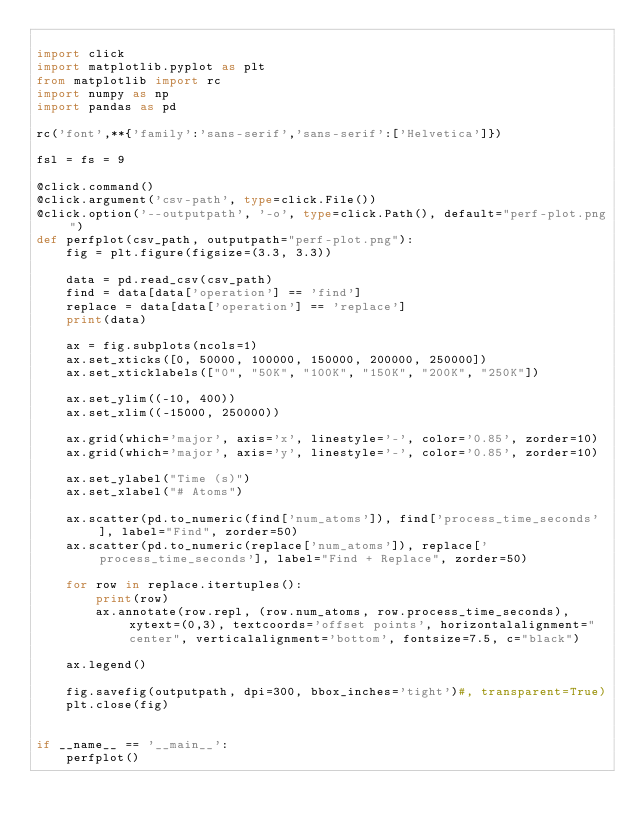<code> <loc_0><loc_0><loc_500><loc_500><_Python_>
import click
import matplotlib.pyplot as plt
from matplotlib import rc
import numpy as np
import pandas as pd

rc('font',**{'family':'sans-serif','sans-serif':['Helvetica']})

fsl = fs = 9

@click.command()
@click.argument('csv-path', type=click.File())
@click.option('--outputpath', '-o', type=click.Path(), default="perf-plot.png")
def perfplot(csv_path, outputpath="perf-plot.png"):
    fig = plt.figure(figsize=(3.3, 3.3))

    data = pd.read_csv(csv_path)
    find = data[data['operation'] == 'find']
    replace = data[data['operation'] == 'replace']
    print(data)

    ax = fig.subplots(ncols=1)
    ax.set_xticks([0, 50000, 100000, 150000, 200000, 250000])
    ax.set_xticklabels(["0", "50K", "100K", "150K", "200K", "250K"])

    ax.set_ylim((-10, 400))
    ax.set_xlim((-15000, 250000))

    ax.grid(which='major', axis='x', linestyle='-', color='0.85', zorder=10)
    ax.grid(which='major', axis='y', linestyle='-', color='0.85', zorder=10)

    ax.set_ylabel("Time (s)")
    ax.set_xlabel("# Atoms")

    ax.scatter(pd.to_numeric(find['num_atoms']), find['process_time_seconds'], label="Find", zorder=50)
    ax.scatter(pd.to_numeric(replace['num_atoms']), replace['process_time_seconds'], label="Find + Replace", zorder=50)

    for row in replace.itertuples():
        print(row)
        ax.annotate(row.repl, (row.num_atoms, row.process_time_seconds), xytext=(0,3), textcoords='offset points', horizontalalignment="center", verticalalignment='bottom', fontsize=7.5, c="black")

    ax.legend()

    fig.savefig(outputpath, dpi=300, bbox_inches='tight')#, transparent=True)
    plt.close(fig)


if __name__ == '__main__':
    perfplot()
</code> 